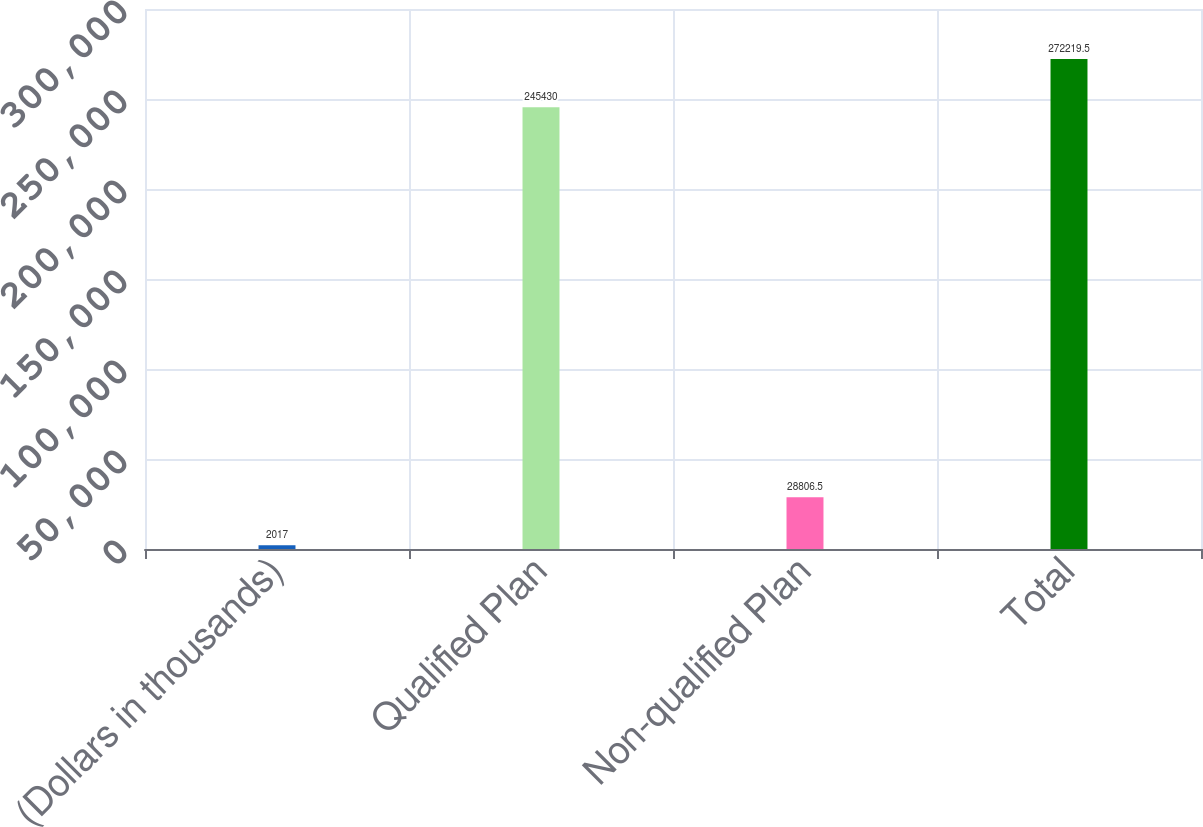Convert chart. <chart><loc_0><loc_0><loc_500><loc_500><bar_chart><fcel>(Dollars in thousands)<fcel>Qualified Plan<fcel>Non-qualified Plan<fcel>Total<nl><fcel>2017<fcel>245430<fcel>28806.5<fcel>272220<nl></chart> 